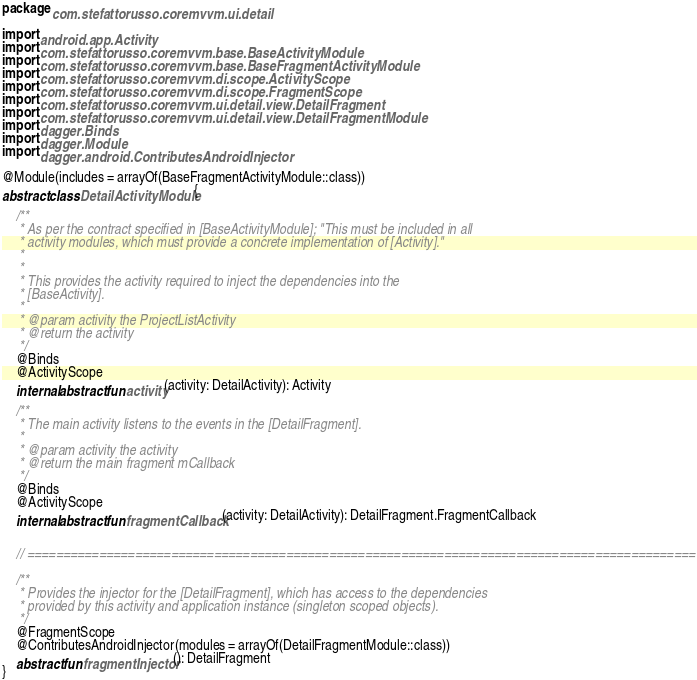<code> <loc_0><loc_0><loc_500><loc_500><_Kotlin_>package com.stefattorusso.coremvvm.ui.detail

import android.app.Activity
import com.stefattorusso.coremvvm.base.BaseActivityModule
import com.stefattorusso.coremvvm.base.BaseFragmentActivityModule
import com.stefattorusso.coremvvm.di.scope.ActivityScope
import com.stefattorusso.coremvvm.di.scope.FragmentScope
import com.stefattorusso.coremvvm.ui.detail.view.DetailFragment
import com.stefattorusso.coremvvm.ui.detail.view.DetailFragmentModule
import dagger.Binds
import dagger.Module
import dagger.android.ContributesAndroidInjector

@Module(includes = arrayOf(BaseFragmentActivityModule::class))
abstract class DetailActivityModule {

    /**
     * As per the contract specified in [BaseActivityModule]; "This must be included in all
     * activity modules, which must provide a concrete implementation of [Activity]."
     *
     *
     * This provides the activity required to inject the dependencies into the
     * [BaseActivity].
     *
     * @param activity the ProjectListActivity
     * @return the activity
     */
    @Binds
    @ActivityScope
    internal abstract fun activity(activity: DetailActivity): Activity

    /**
     * The main activity listens to the events in the [DetailFragment].
     *
     * @param activity the activity
     * @return the main fragment mCallback
     */
    @Binds
    @ActivityScope
    internal abstract fun fragmentCallback(activity: DetailActivity): DetailFragment.FragmentCallback


    // =============================================================================================

    /**
     * Provides the injector for the [DetailFragment], which has access to the dependencies
     * provided by this activity and application instance (singleton scoped objects).
     */
    @FragmentScope
    @ContributesAndroidInjector(modules = arrayOf(DetailFragmentModule::class))
    abstract fun fragmentInjector(): DetailFragment
}</code> 